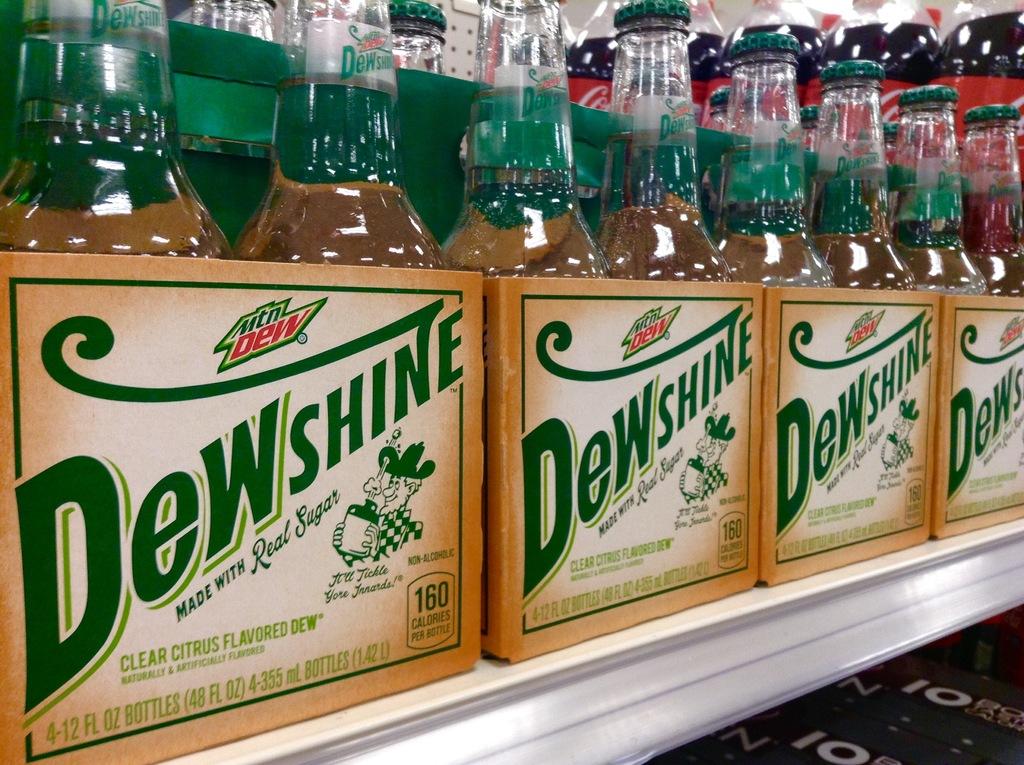Who created dewshine?
Offer a very short reply. Mtn dew. How many calories per serving?
Keep it short and to the point. 160. 